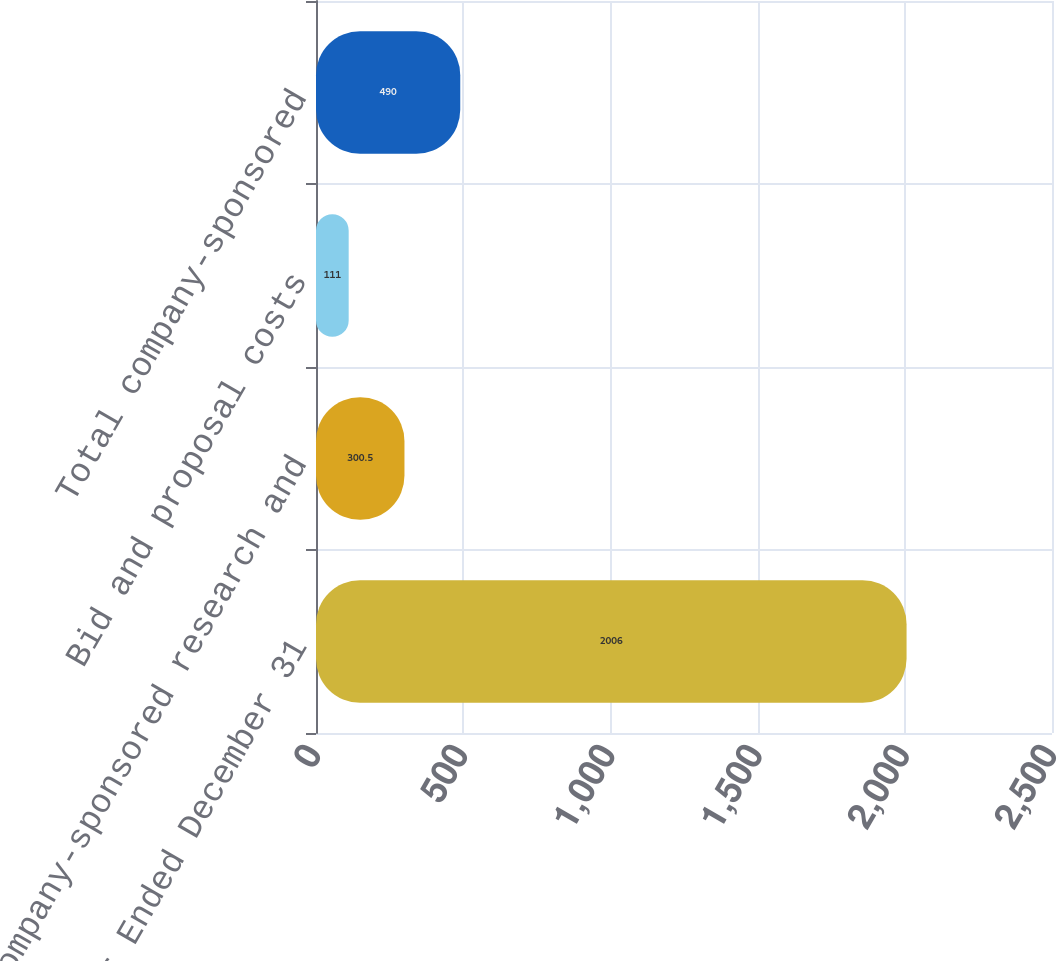Convert chart. <chart><loc_0><loc_0><loc_500><loc_500><bar_chart><fcel>Year Ended December 31<fcel>Company-sponsored research and<fcel>Bid and proposal costs<fcel>Total company-sponsored<nl><fcel>2006<fcel>300.5<fcel>111<fcel>490<nl></chart> 